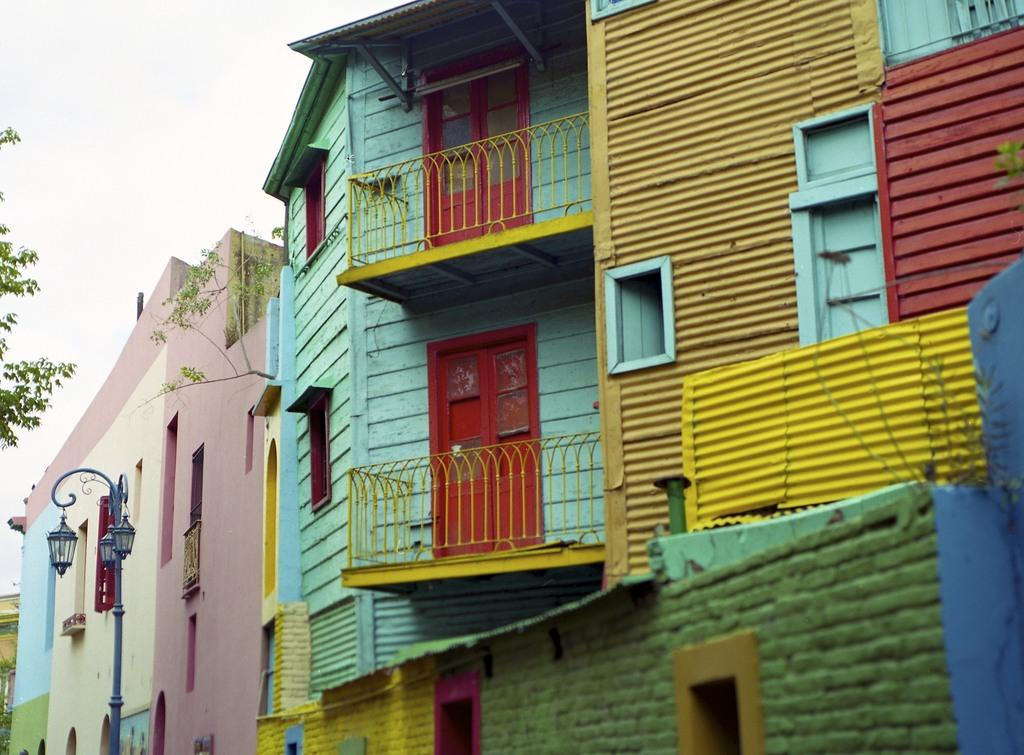What type of structures can be seen in the image? There are buildings in the image. What feature is present near the buildings? Railings are present in the image. What can be seen illuminating the area in the image? Lights are visible in the image. What object is present in the image that is typically used for support or attachment? There is a pole in the image. What type of natural elements are present in the image? Leaves are present in the image. What is visible in the background of the image? The sky is visible in the background of the image. What type of appliance can be seen plugged into the pole in the image? There is no appliance present in the image, and the pole is not shown to have any electrical outlets. What color is the button on the leaves in the image? There is no button present on the leaves in the image; they are natural elements and do not have buttons. 